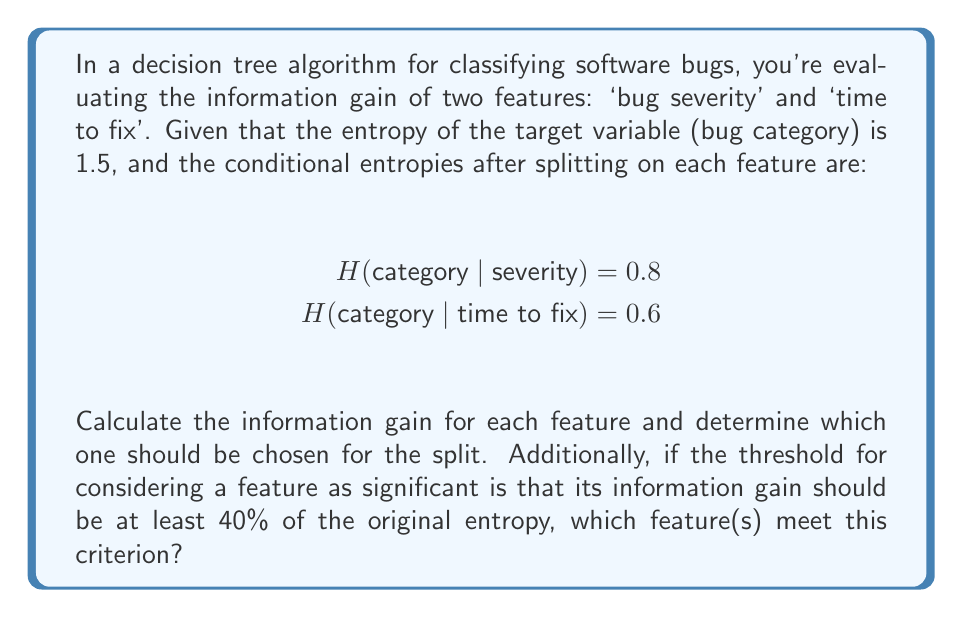Could you help me with this problem? Let's approach this step-by-step:

1) The formula for information gain is:
   $$ IG(Y, X) = H(Y) - H(Y|X) $$
   where $H(Y)$ is the entropy of the target variable and $H(Y|X)$ is the conditional entropy after splitting on feature $X$.

2) For 'bug severity':
   $$ IG(category, severity) = H(category) - H(category | severity) $$
   $$ = 1.5 - 0.8 = 0.7 $$

3) For 'time to fix':
   $$ IG(category, time to fix) = H(category) - H(category | time to fix) $$
   $$ = 1.5 - 0.6 = 0.9 $$

4) Comparing the two, we see that 'time to fix' has higher information gain (0.9 > 0.7), so it should be chosen for the split.

5) To check if a feature meets the significance criterion:
   The threshold is 40% of the original entropy: $0.4 * 1.5 = 0.6$

   - For 'bug severity': $0.7 > 0.6$, so it meets the criterion
   - For 'time to fix': $0.9 > 0.6$, so it also meets the criterion

Therefore, both features meet the significance criterion.
Answer: 'Time to fix' should be chosen (IG = 0.9). Both features are significant. 